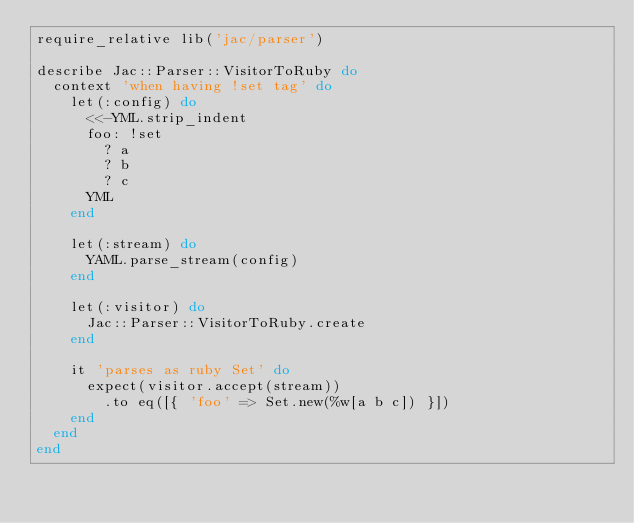<code> <loc_0><loc_0><loc_500><loc_500><_Ruby_>require_relative lib('jac/parser')

describe Jac::Parser::VisitorToRuby do
  context 'when having !set tag' do
    let(:config) do
      <<-YML.strip_indent
      foo: !set
        ? a
        ? b
        ? c
      YML
    end

    let(:stream) do
      YAML.parse_stream(config)
    end

    let(:visitor) do
      Jac::Parser::VisitorToRuby.create
    end

    it 'parses as ruby Set' do
      expect(visitor.accept(stream))
        .to eq([{ 'foo' => Set.new(%w[a b c]) }])
    end
  end
end
</code> 